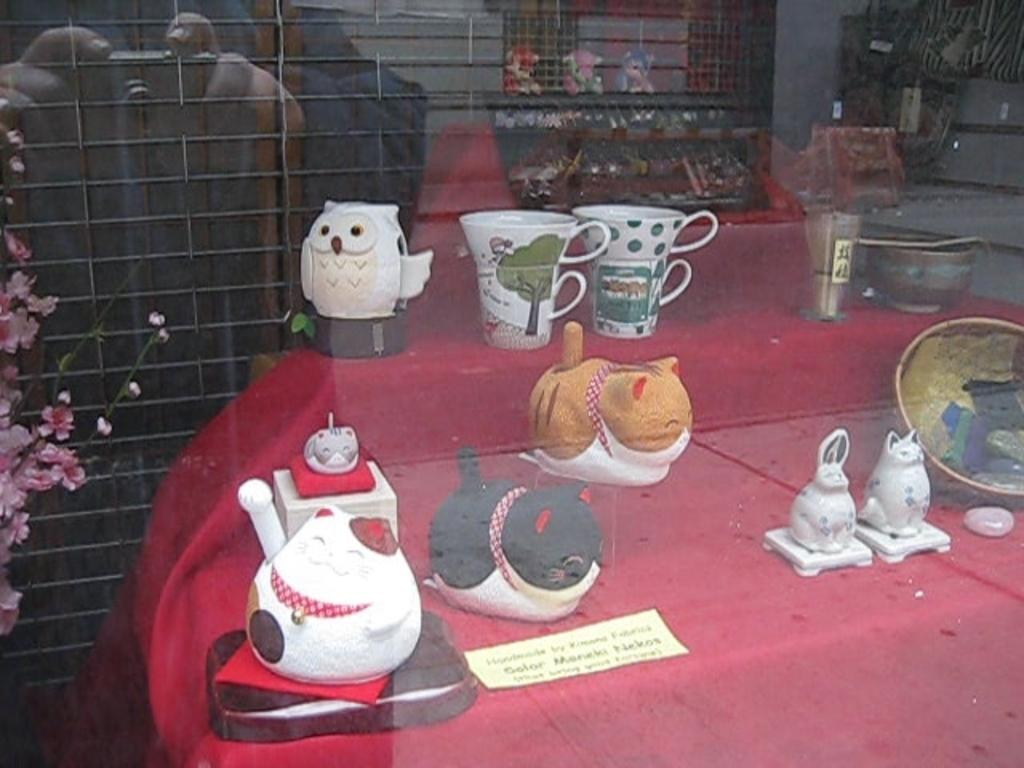What objects are on the table in the image? There are cups and toys on the table in the image. What is located to the left of the table? There is a flower vase to the left of the table. Can you describe the person in the image? A person holding the camera is visible in the background. How is the image captured? The image can be seen through glass. What type of cabbage is growing on the roof in the image? There is no cabbage or roof present in the image. Can you describe the wave pattern on the tablecloth in the image? There is no tablecloth or wave pattern visible in the image. 